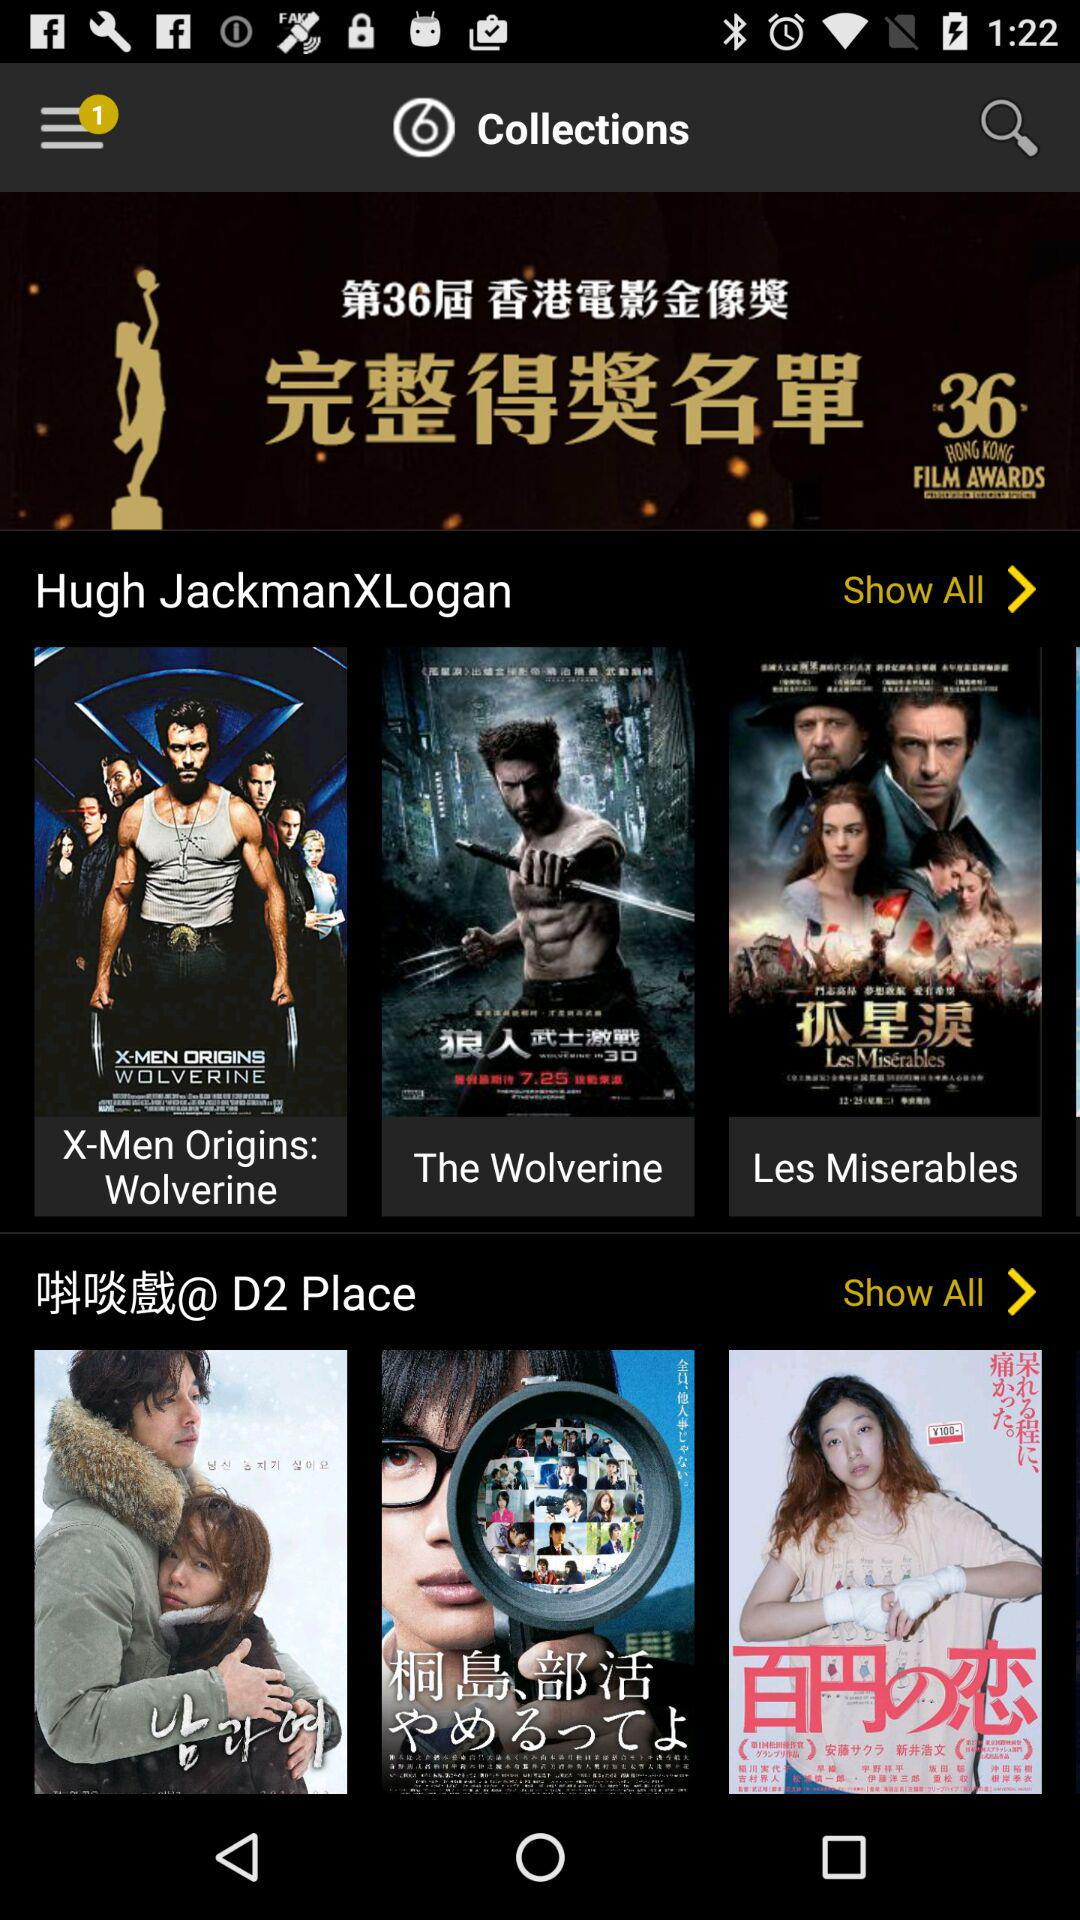What is the count of notifications? The count of notifications is 1. 